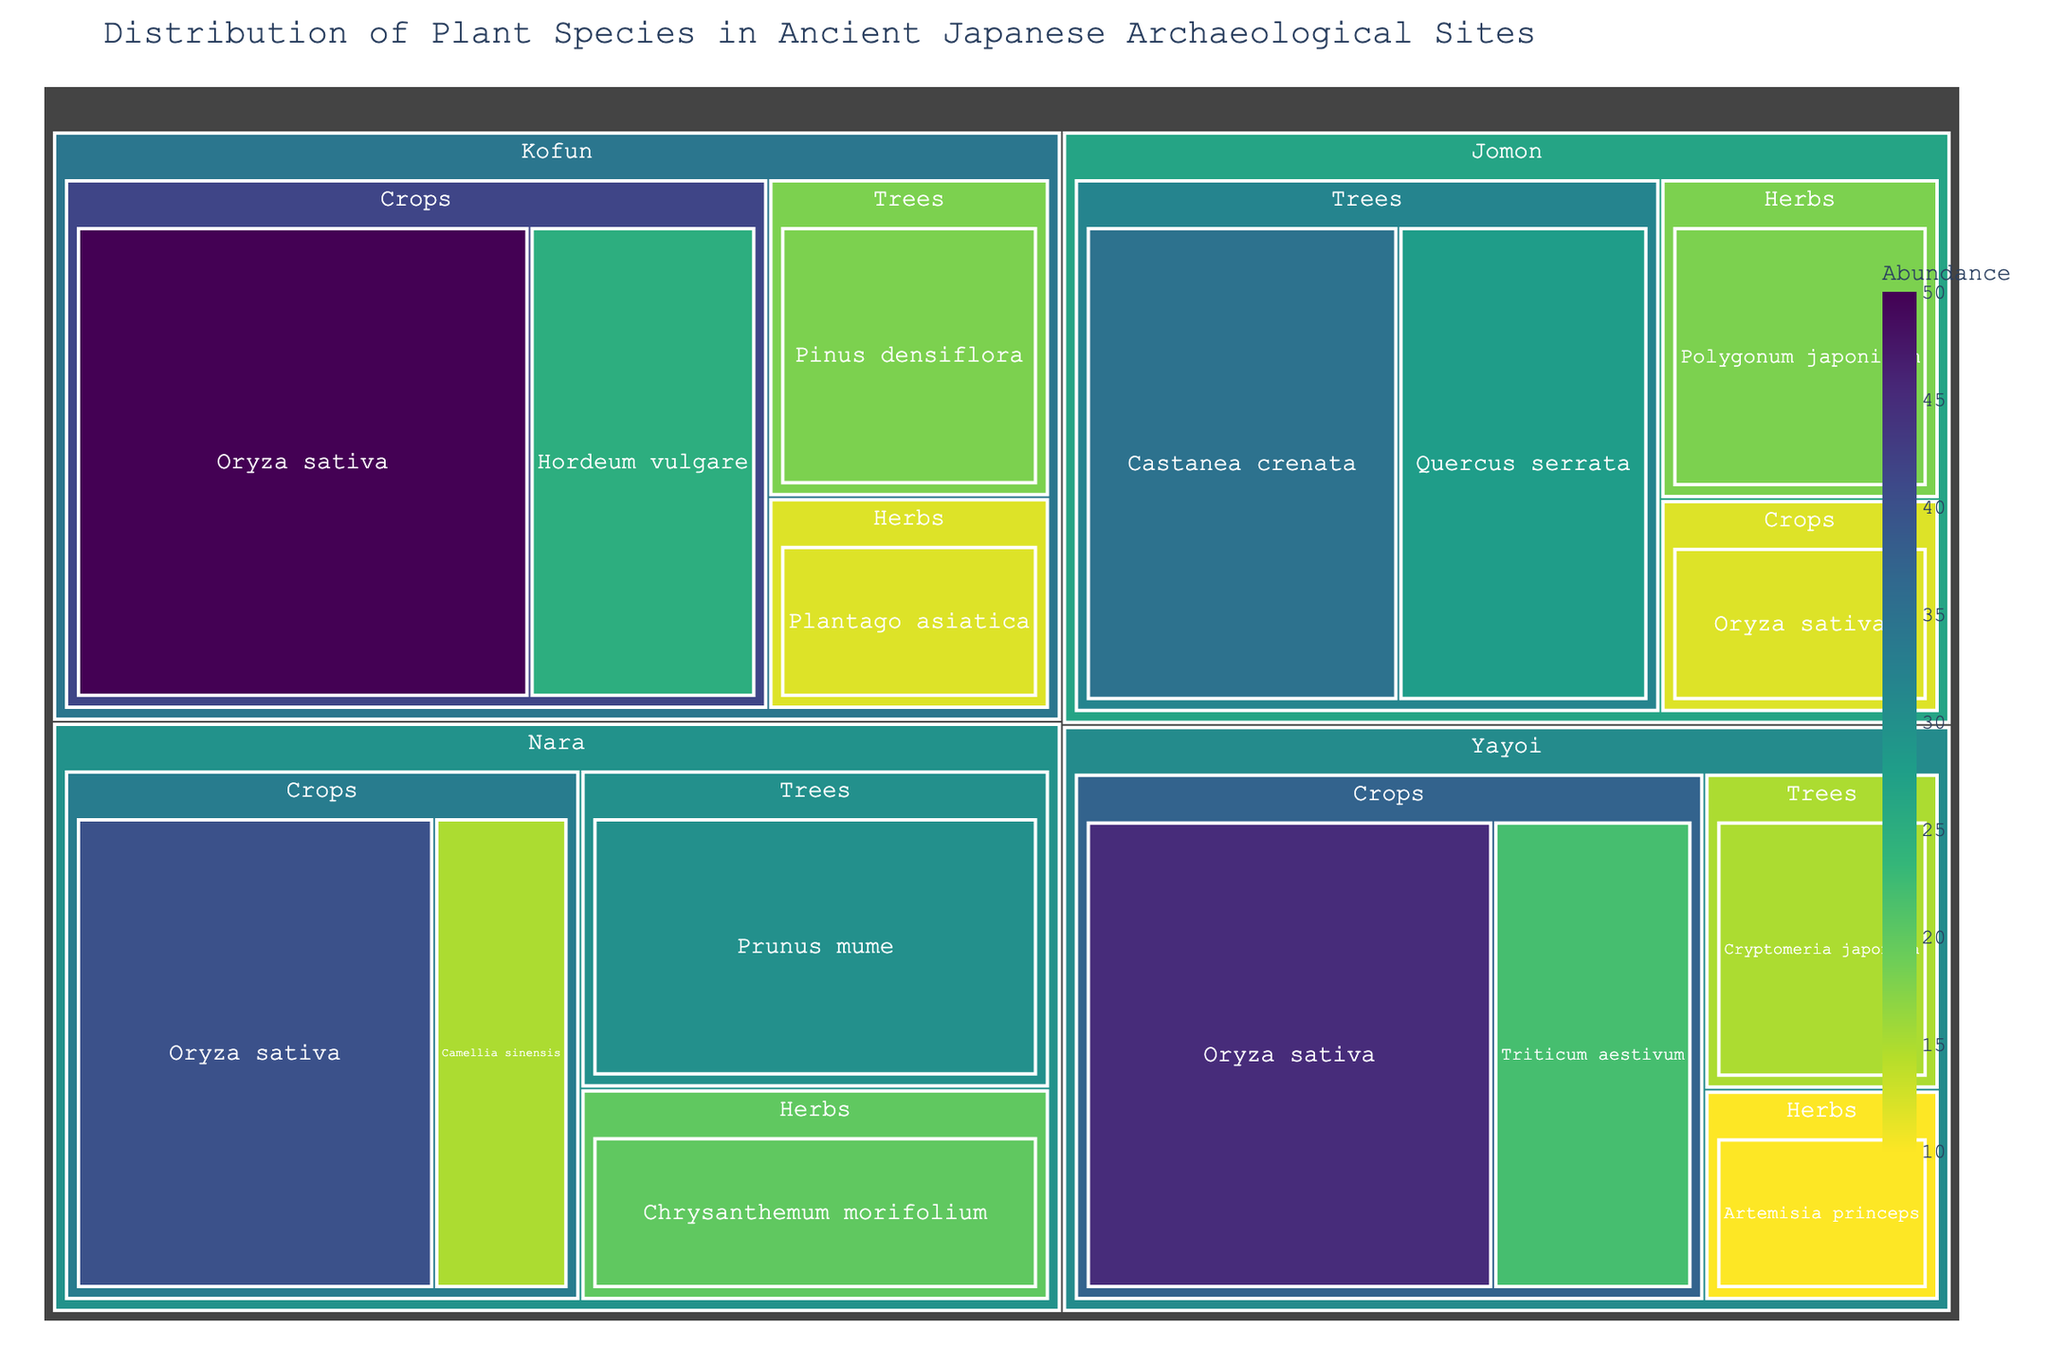What's the title of the treemap? The title of the treemap is typically shown at the top of the figure. This figure is titled 'Distribution of Plant Species in Ancient Japanese Archaeological Sites'.
Answer: Distribution of Plant Species in Ancient Japanese Archaeological Sites Which time period has the highest abundance of Oryza sativa? To find this, locate the species Oryza sativa in each time period and compare their abundances. It appears in the Jomon (12), Yayoi (45), Kofun (50), and Nara (40) periods. The highest abundance is in the Kofun period with 50.
Answer: Kofun period What is the total abundance of plant species in the Jomon period? Add the abundances of all species in the Jomon period: Castanea crenata (35), Quercus serrata (28), Polygonum japonicum (18), and Oryza sativa (12). The total is \(35 + 28 + 18 + 12 = 93\).
Answer: 93 Which plant group has the greatest diversity of species in the Nara period? Look at the Nara period and count the species in each plant group: Crops (Oryza sativa, Camellia sinensis - 2 species), Trees (Prunus mume - 1 species), and Herbs (Chrysanthemum morifolium - 1 species). Crops have the greatest diversity with 2 species.
Answer: Crops During which time period are Herbs least abundant? Examine the herbs across all periods: Jomon (18), Yayoi (10), Kofun (12), and Nara (20). The Yayoi period has the least abundance for herbs, with 10.
Answer: Yayoi period How does the abundance of Quercus serrata in the Jomon period compare to the abundance of Prunus mume in the Nara period? Compare the values for Quercus serrata in the Jomon period (28) to Prunus mume in the Nara period (30). Prunus mume has a higher abundance than Quercus serrata.
Answer: Prunus mume is higher Is Oryza sativa more abundant in the Yayoi or Kofun period? Compare the abundance of Oryza sativa in the Yayoi period (45) to the Kofun period (50). It is more abundant in the Kofun period.
Answer: Kofun period Which time period has the least total abundance of plant species? Sum the abundances of all plant species in each period: Jomon (93), Yayoi (92), Kofun (105), Nara (105). The Yayoi period has the least total abundance at 92.
Answer: Yayoi period 